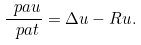<formula> <loc_0><loc_0><loc_500><loc_500>\frac { \ p a u } { \ p a t } = \Delta u - R u .</formula> 